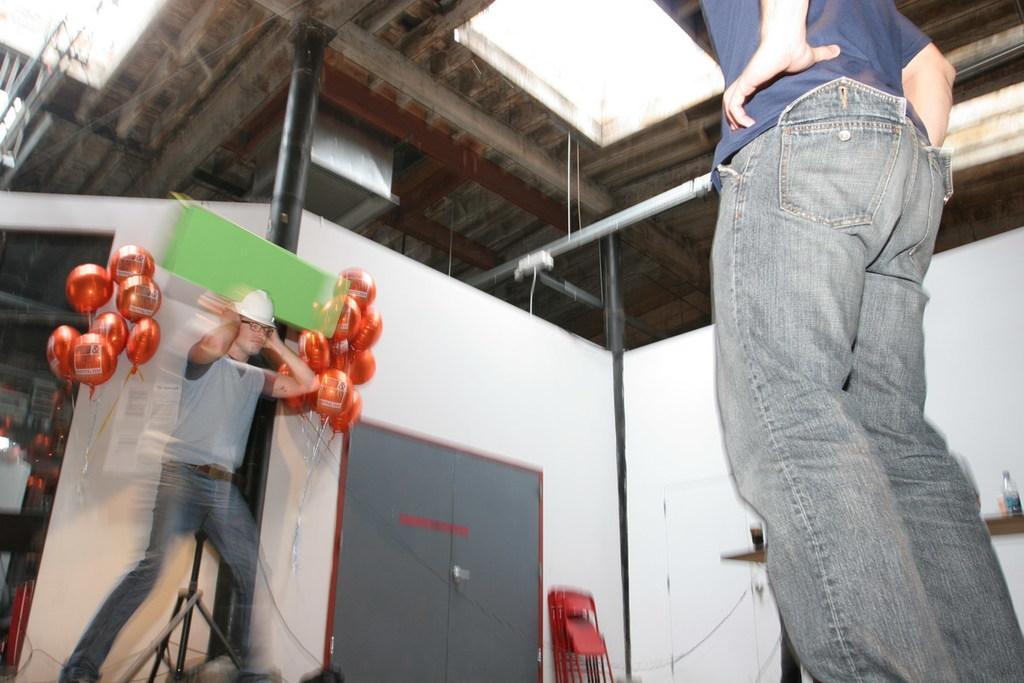In one or two sentences, can you explain what this image depicts? In this image on the right side there is one person standing, and on the left side there is another person and some balloons. And in the center there is a door and some chairs and poles, at the top there is ceiling and on the left side there are some objects and on the right side also there are some objects. 